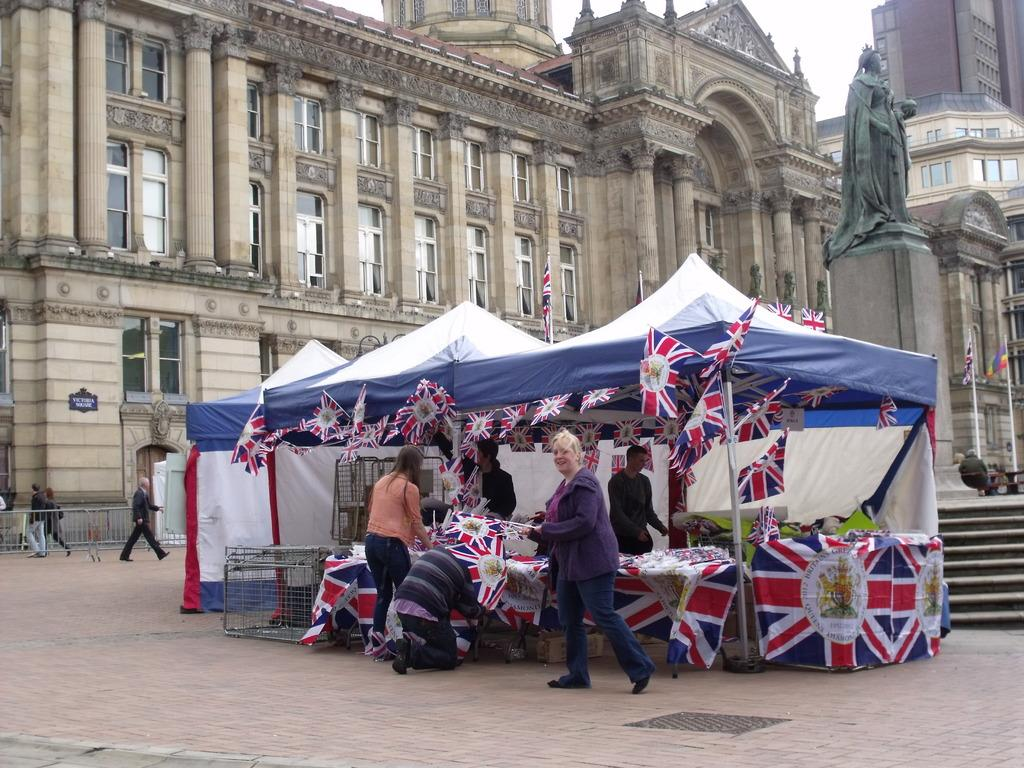Who or what is present in the image? There are people in the image. What structure can be seen in the image? There is a tent in the image. What additional objects are present in the image? There are flags in the image. What can be seen in the background of the image? There is a statue and buildings visible in the background of the image. What type of pie is being served at the event in the image? There is no indication of any food, including pie, being served in the image. 